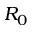<formula> <loc_0><loc_0><loc_500><loc_500>R _ { 0 }</formula> 